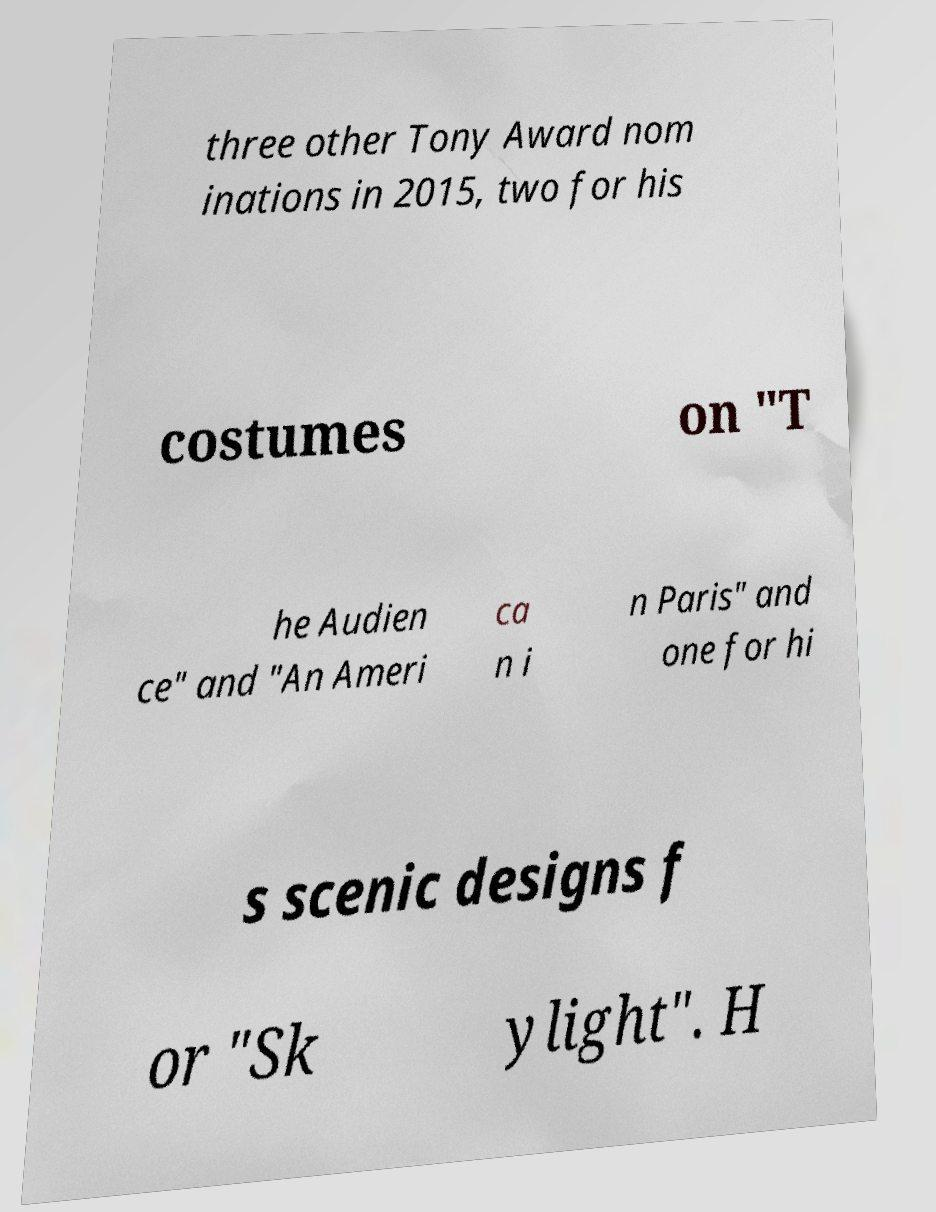Please identify and transcribe the text found in this image. three other Tony Award nom inations in 2015, two for his costumes on "T he Audien ce" and "An Ameri ca n i n Paris" and one for hi s scenic designs f or "Sk ylight". H 